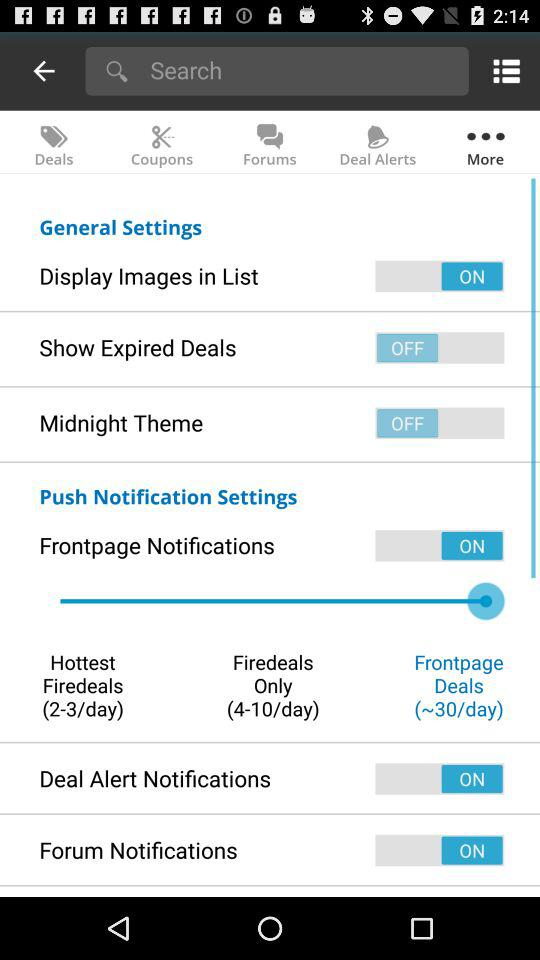How many "Hottest Firedeals" per day? There are 2-3 "Hottest Firedeals" per day. 